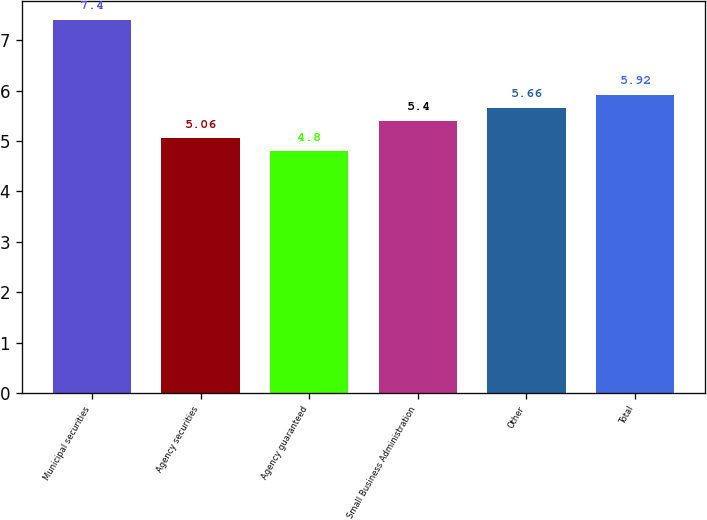<chart> <loc_0><loc_0><loc_500><loc_500><bar_chart><fcel>Municipal securities<fcel>Agency securities<fcel>Agency guaranteed<fcel>Small Business Administration<fcel>Other<fcel>Total<nl><fcel>7.4<fcel>5.06<fcel>4.8<fcel>5.4<fcel>5.66<fcel>5.92<nl></chart> 